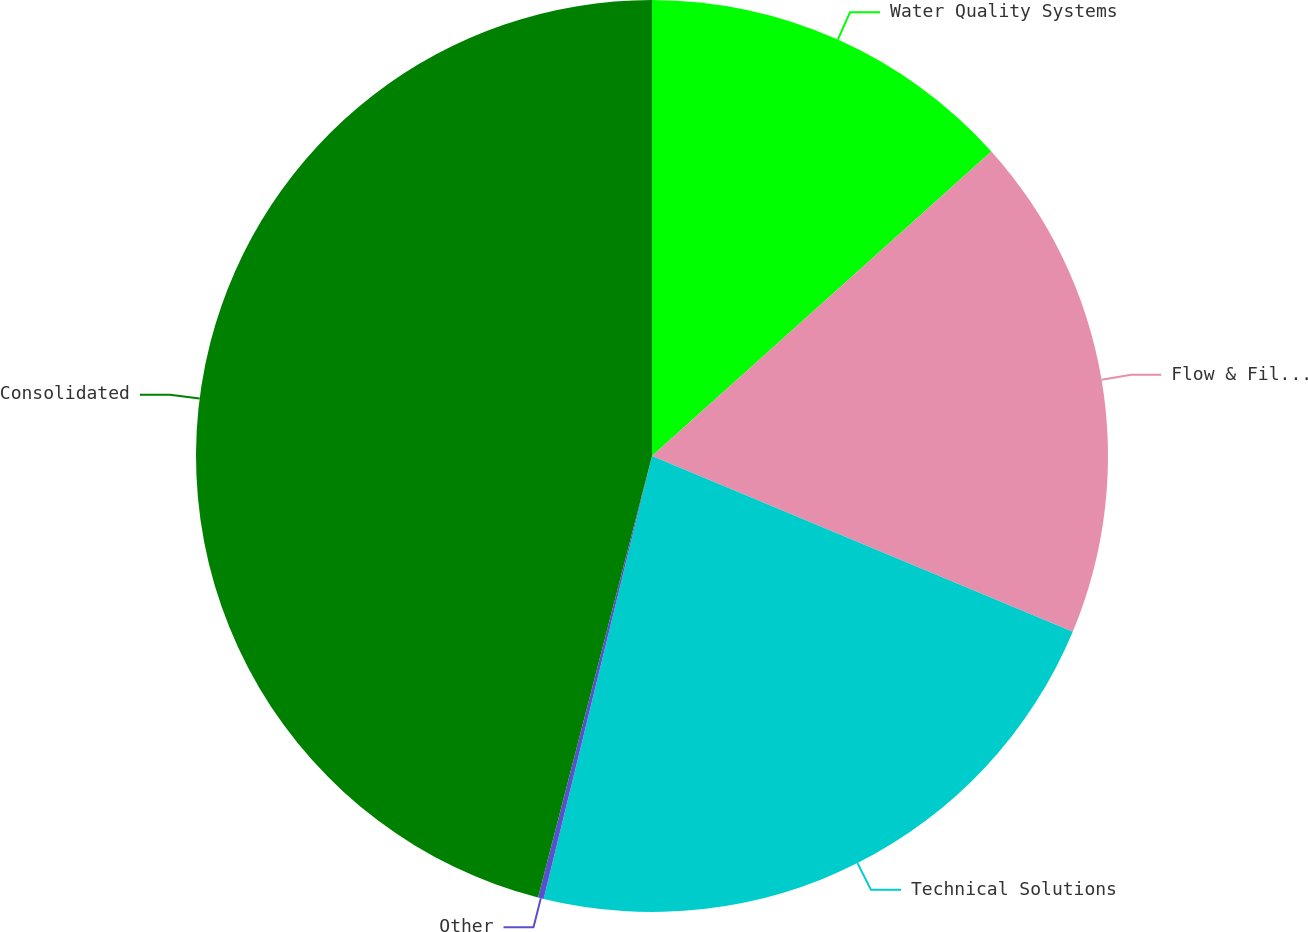Convert chart to OTSL. <chart><loc_0><loc_0><loc_500><loc_500><pie_chart><fcel>Water Quality Systems<fcel>Flow & Filtration Solutions<fcel>Technical Solutions<fcel>Other<fcel>Consolidated<nl><fcel>13.36%<fcel>17.94%<fcel>22.52%<fcel>0.2%<fcel>45.98%<nl></chart> 